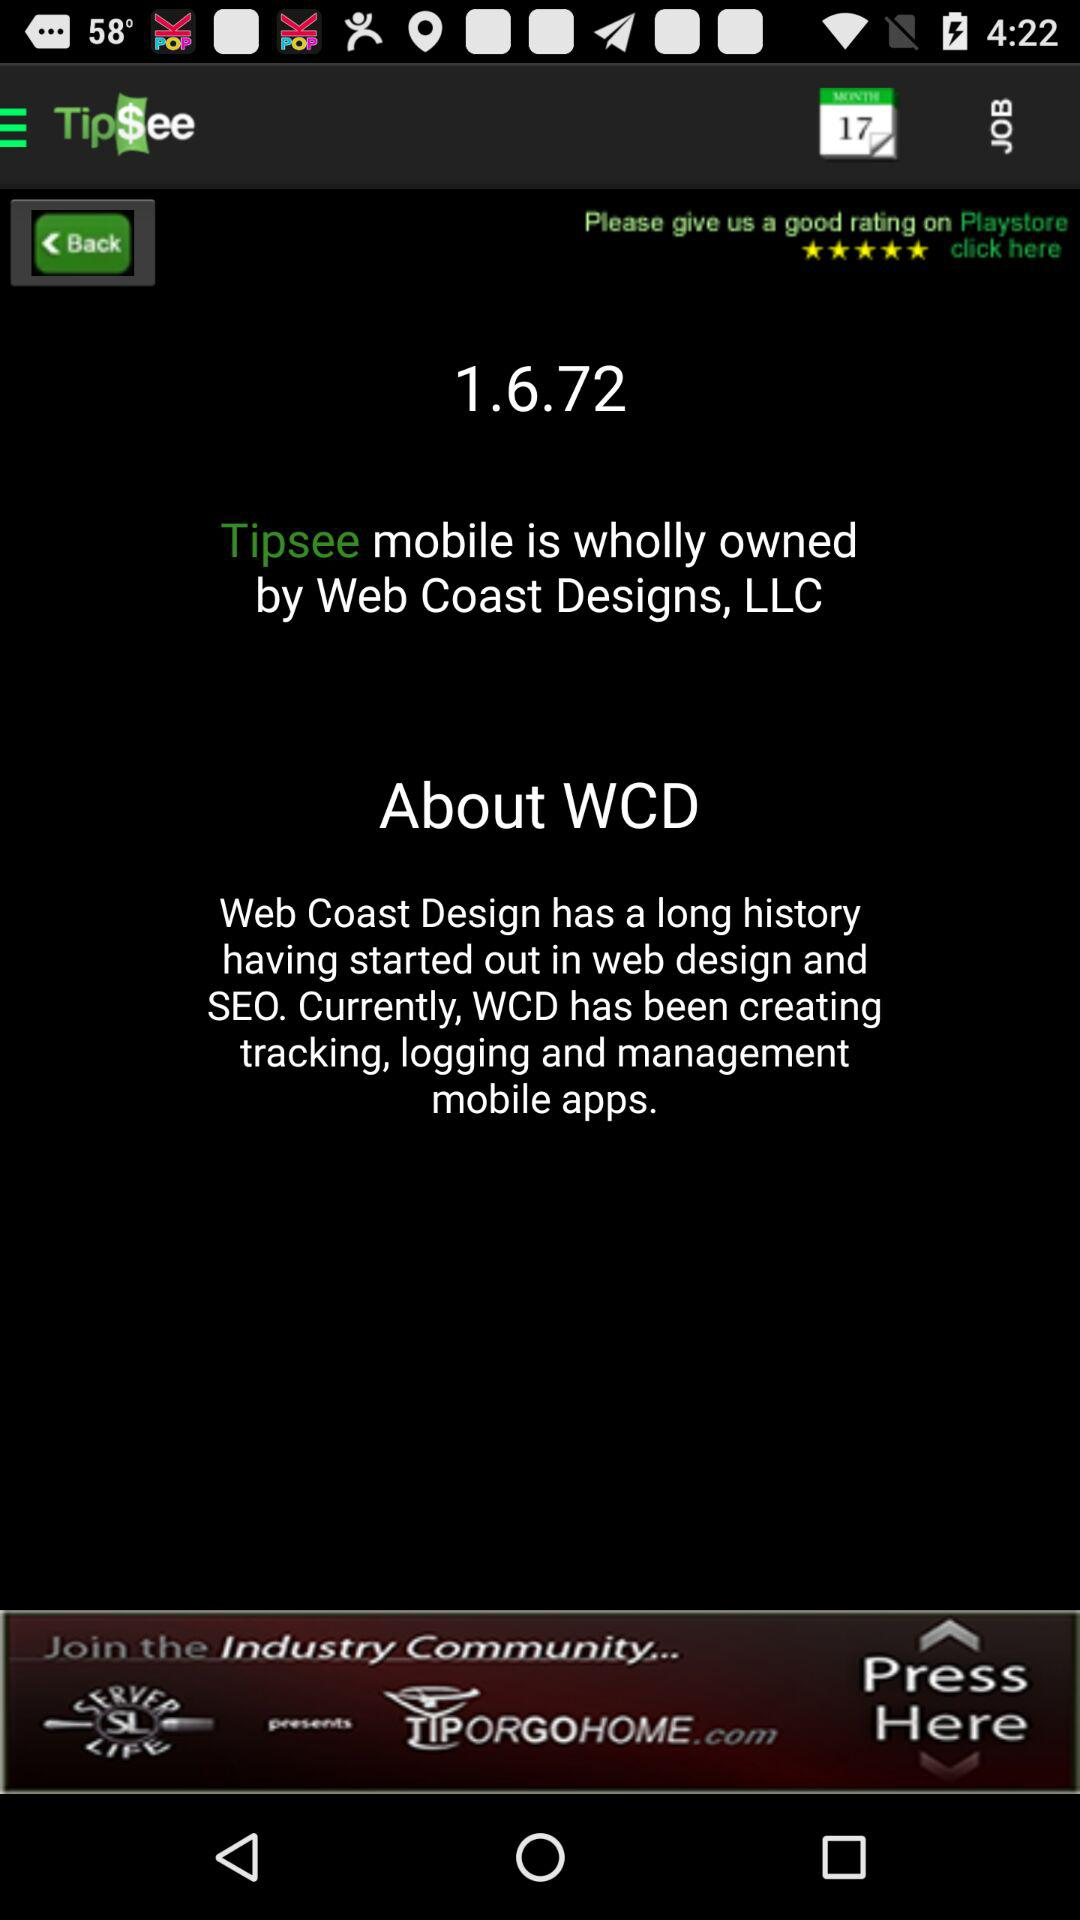What is the name of the application? The name of the application is "Tip$ee". 